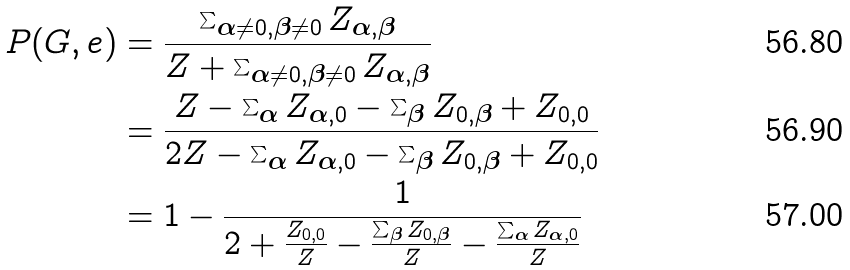<formula> <loc_0><loc_0><loc_500><loc_500>P ( G , e ) & = \frac { \sum _ { \boldsymbol \alpha \neq 0 , \boldsymbol \beta \neq 0 } Z _ { \boldsymbol \alpha , \boldsymbol \beta } } { Z + \sum _ { \boldsymbol \alpha \neq 0 , \boldsymbol \beta \neq 0 } Z _ { \boldsymbol \alpha , \boldsymbol \beta } } \\ & = \frac { Z - \sum _ { \boldsymbol \alpha } Z _ { \boldsymbol \alpha , 0 } - \sum _ { \boldsymbol \beta } Z _ { 0 , \boldsymbol \beta } + Z _ { 0 , 0 } } { 2 Z - \sum _ { \boldsymbol \alpha } Z _ { \boldsymbol \alpha , 0 } - \sum _ { \boldsymbol \beta } Z _ { 0 , \boldsymbol \beta } + Z _ { 0 , 0 } } \\ & = 1 - \frac { 1 } { 2 + \frac { Z _ { 0 , 0 } } { Z } - \frac { \sum _ { \boldsymbol \beta } Z _ { 0 , \boldsymbol \beta } } { Z } - \frac { \sum _ { \boldsymbol \alpha } Z _ { \boldsymbol \alpha , 0 } } { Z } }</formula> 